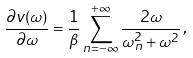<formula> <loc_0><loc_0><loc_500><loc_500>\frac { \partial v ( \omega ) } { \partial \omega } = \frac { 1 } { \beta } \sum _ { n = - \infty } ^ { + \infty } \frac { 2 \omega } { \omega _ { n } ^ { 2 } + \omega ^ { 2 } } \, ,</formula> 